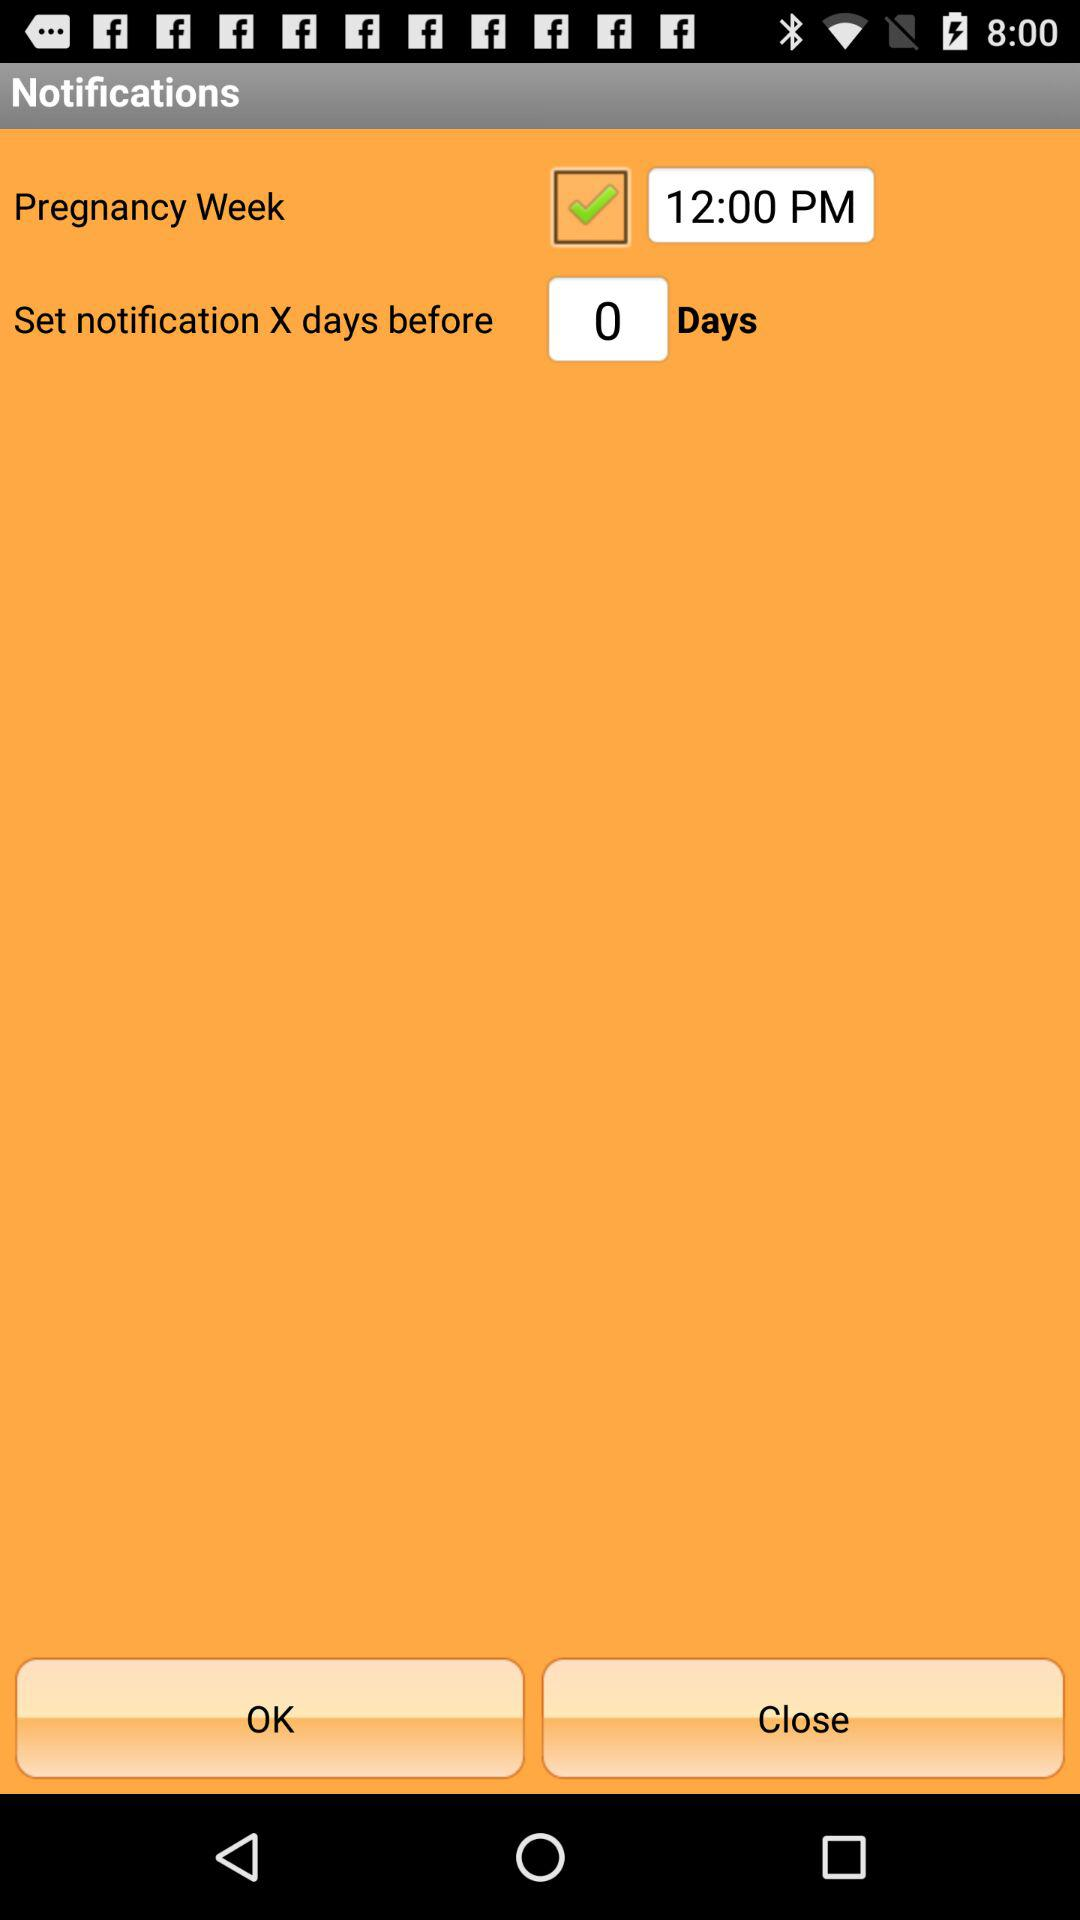What's the number of given days for "set notification X days before"? The number of given days is 0. 